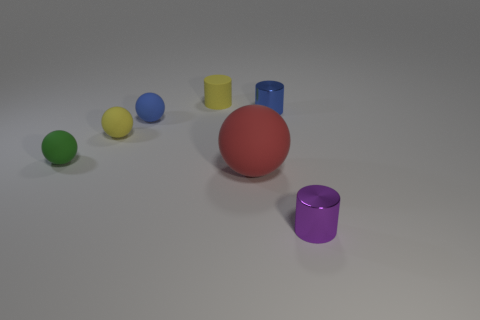There is a tiny rubber object that is the same color as the matte cylinder; what is its shape?
Your response must be concise. Sphere. What material is the purple object that is the same shape as the blue metallic object?
Offer a very short reply. Metal. There is a blue thing that is to the left of the large red matte thing; does it have the same size as the rubber object that is in front of the green rubber thing?
Make the answer very short. No. There is a tiny yellow sphere left of the large red matte object; how many red matte objects are in front of it?
Your response must be concise. 1. Are there any large red spheres?
Provide a short and direct response. Yes. How many other objects are the same color as the big thing?
Ensure brevity in your answer.  0. Is the number of tiny yellow matte cylinders less than the number of large yellow rubber balls?
Offer a very short reply. No. There is a small green thing that is on the left side of the matte sphere that is behind the yellow sphere; what shape is it?
Provide a succinct answer. Sphere. Are there any big red rubber objects on the left side of the yellow ball?
Your answer should be compact. No. The matte cylinder that is the same size as the green sphere is what color?
Your response must be concise. Yellow. 